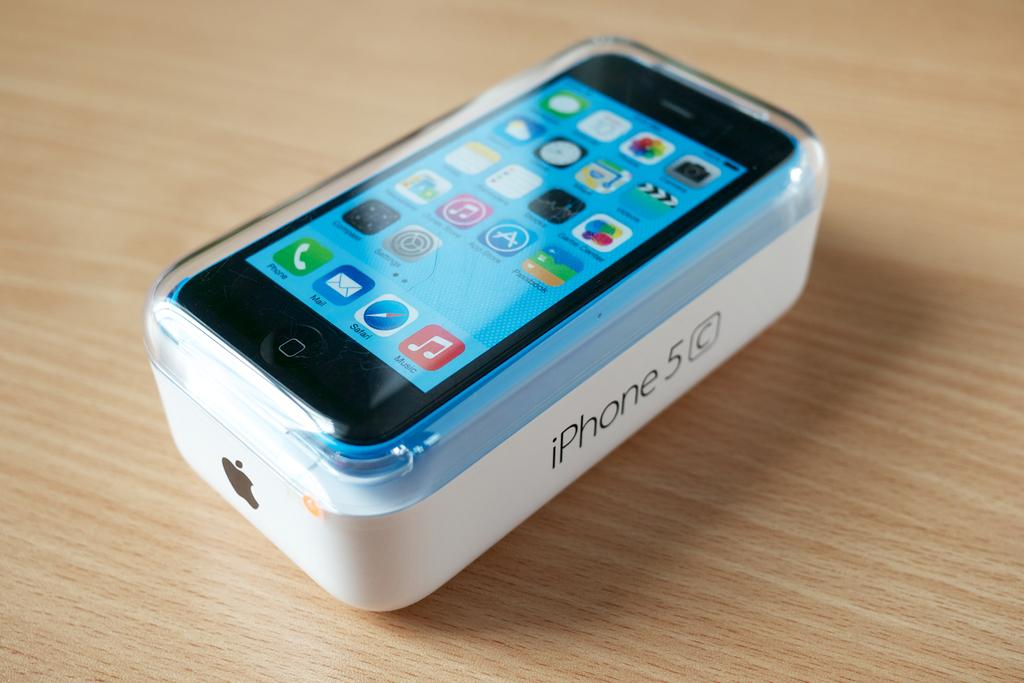<image>
Create a compact narrative representing the image presented. iPhone 5C placed on top of the box on top of a table. 